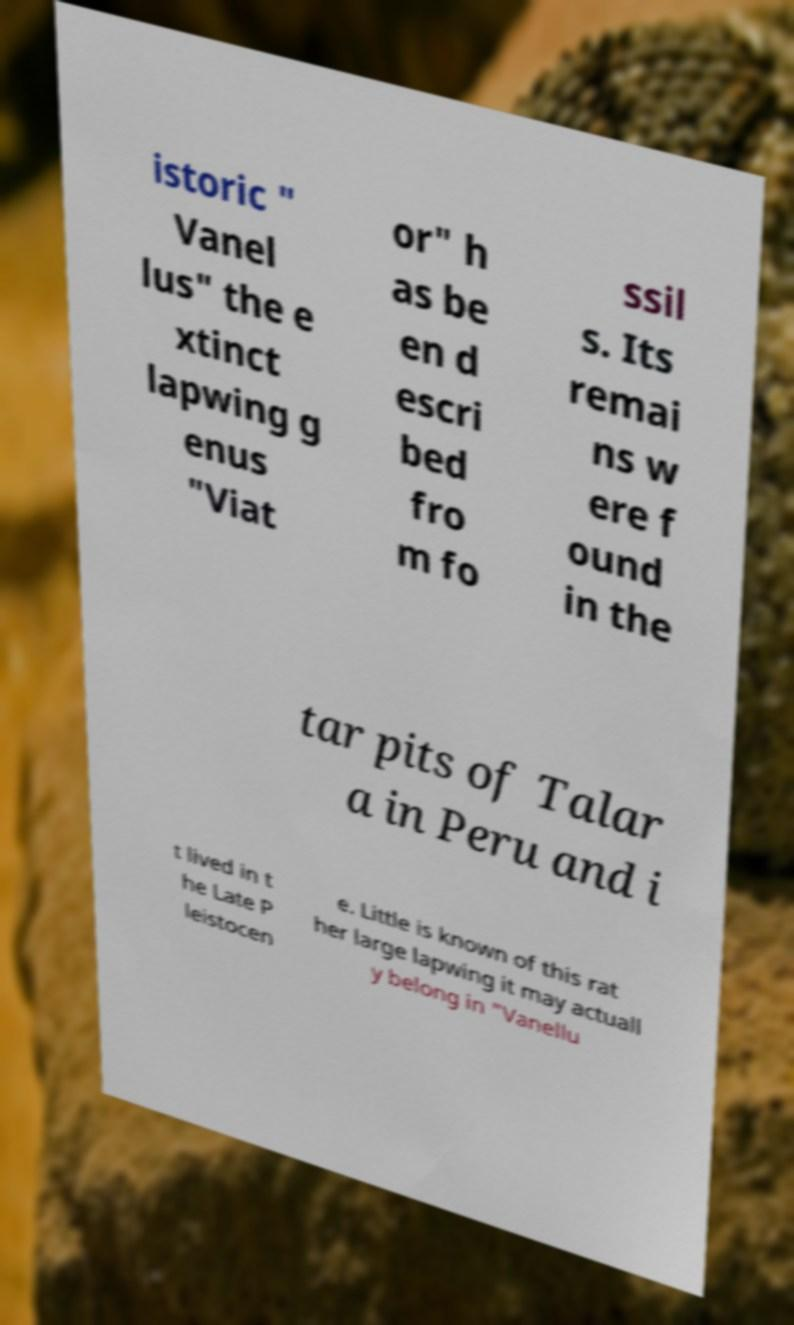Could you extract and type out the text from this image? istoric " Vanel lus" the e xtinct lapwing g enus "Viat or" h as be en d escri bed fro m fo ssil s. Its remai ns w ere f ound in the tar pits of Talar a in Peru and i t lived in t he Late P leistocen e. Little is known of this rat her large lapwing it may actuall y belong in "Vanellu 